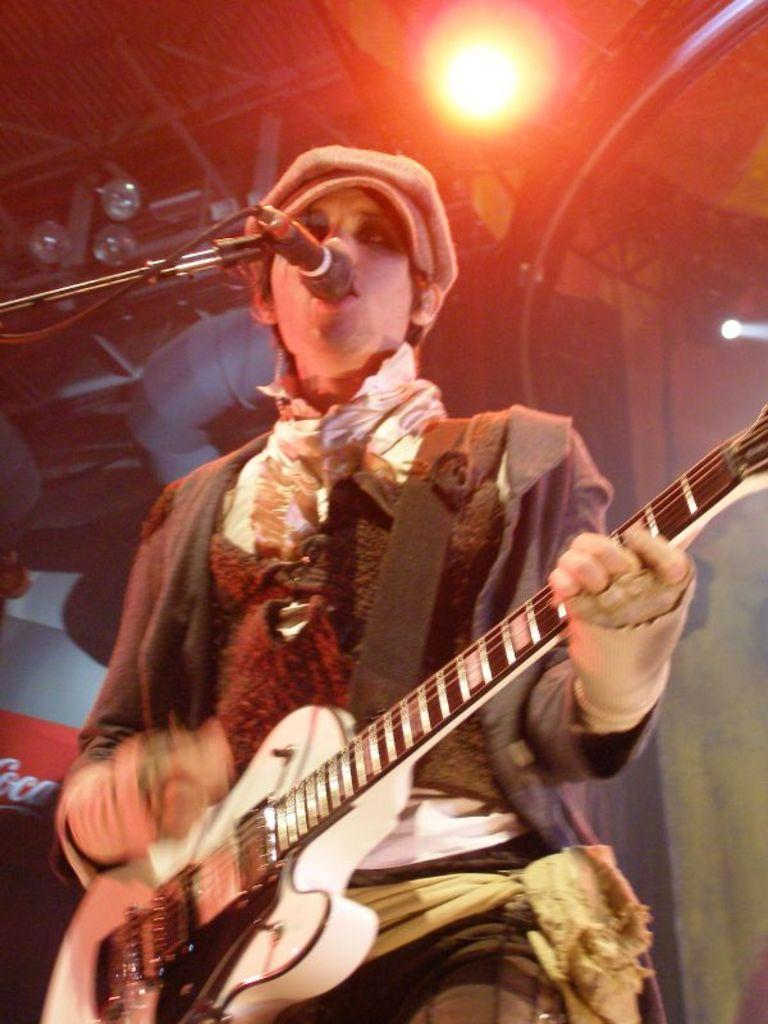What is the man in the image doing? The man is playing the guitar and singing. What instrument is the man holding in the image? The man is holding a guitar in the image. How is the man's voice being amplified in the image? The man is using a microphone in the image. What can be seen in the background of the image? There is a light and a wall in the background of the image. Reasoning: Let' Let's think step by step in order to produce the conversation. We start by identifying the main subject in the image, which is the man. Then, we describe what the man is doing, which includes playing the guitar, singing, and using a microphone. We also mention the presence of a light and a wall in the background of the image. Each question is designed to elicit a specific detail about the image that is known from the provided facts. Absurd Question/Answer: What type of yam is being used as a prop in the image? There is no yam present in the image. What substance is the man using to enhance his performance in the image? The provided facts do not mention any substances being used to enhance the man's performance. 